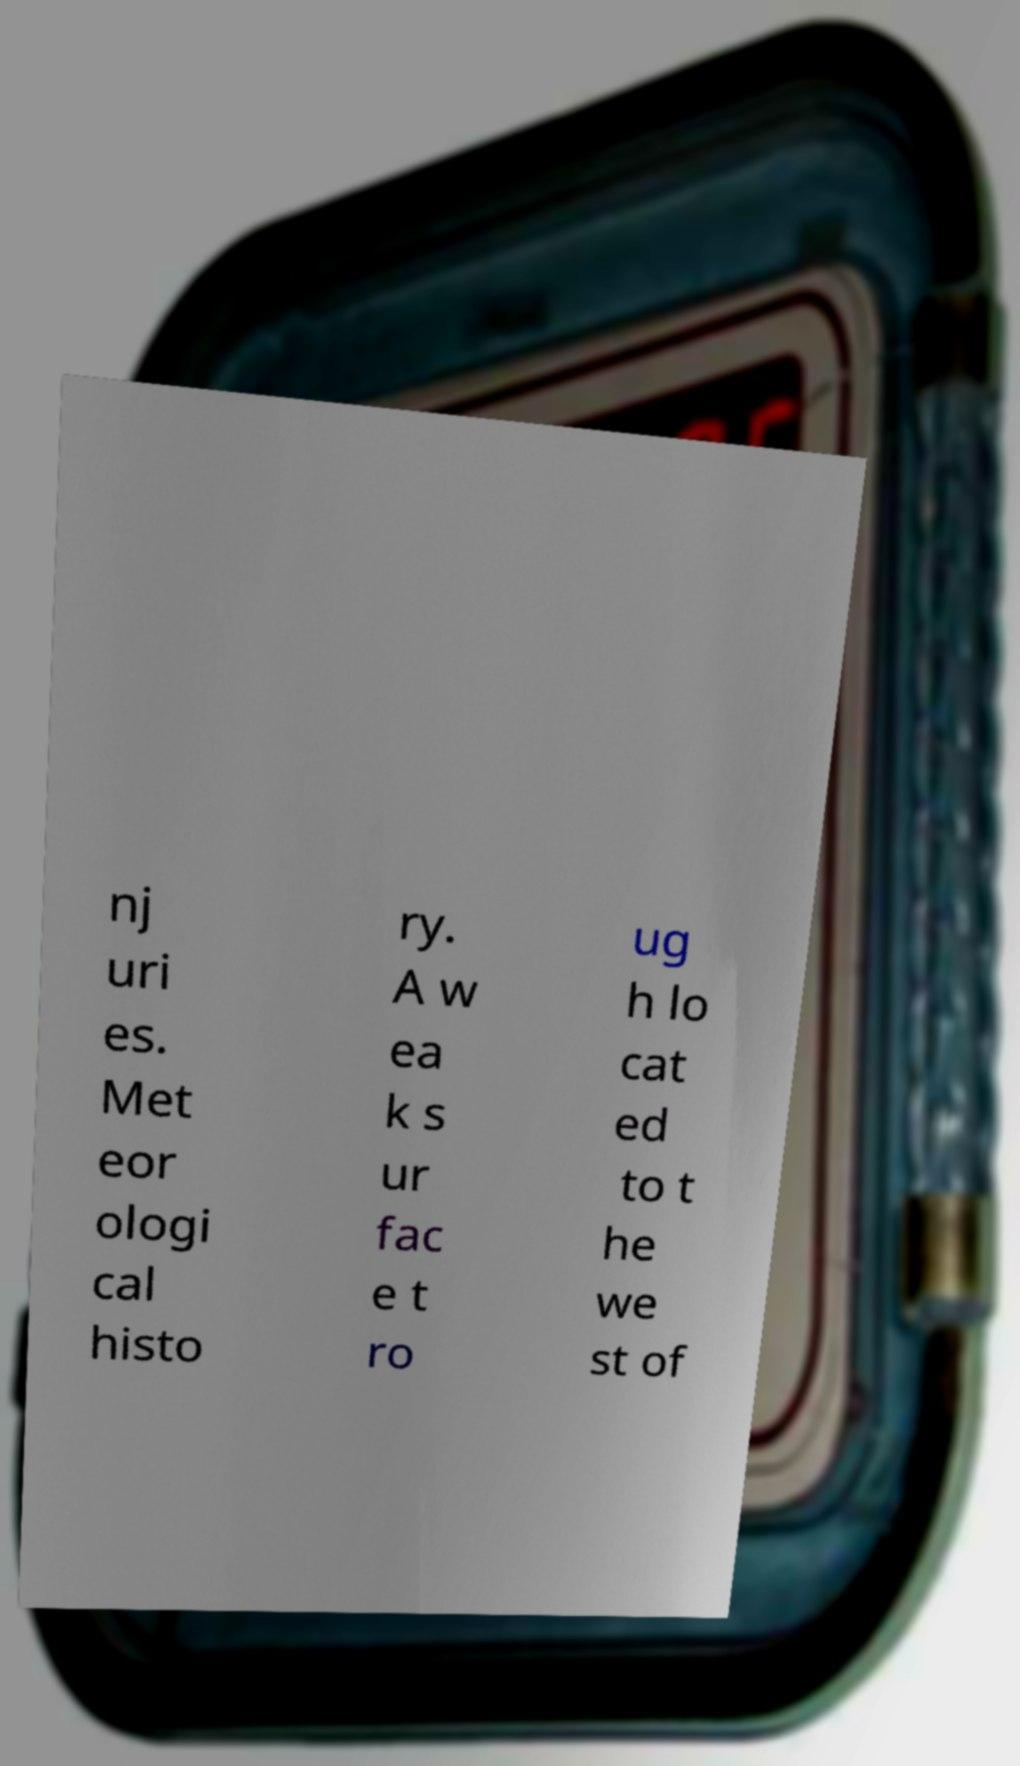There's text embedded in this image that I need extracted. Can you transcribe it verbatim? nj uri es. Met eor ologi cal histo ry. A w ea k s ur fac e t ro ug h lo cat ed to t he we st of 